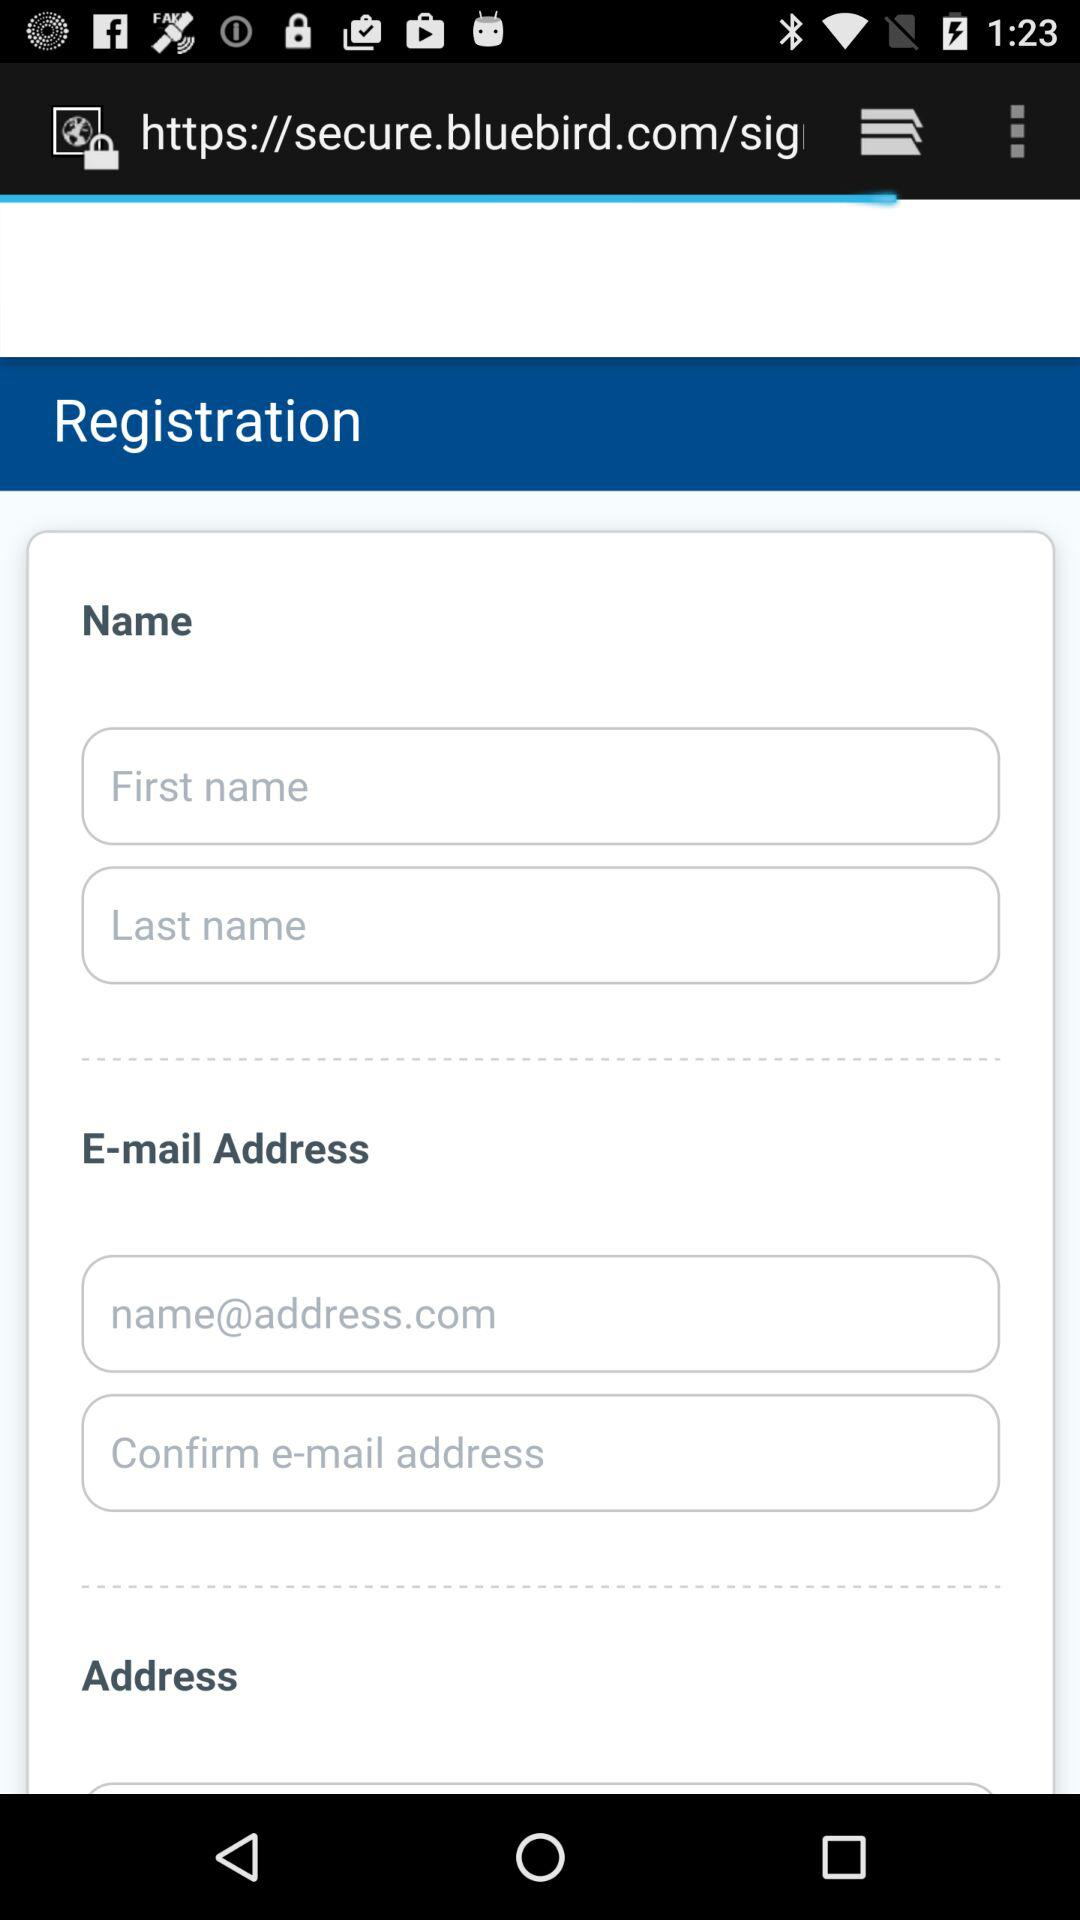How many fields are there for the user to enter their name?
Answer the question using a single word or phrase. 2 